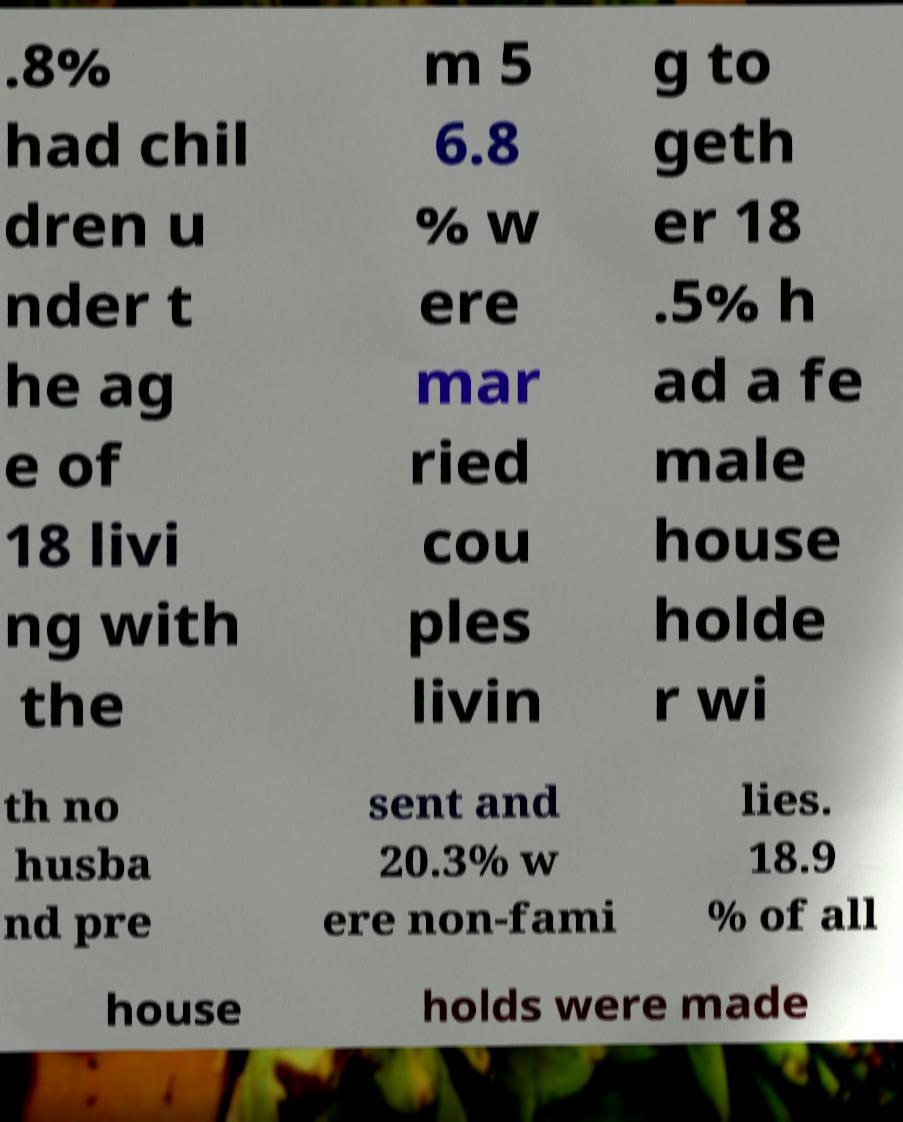Can you accurately transcribe the text from the provided image for me? .8% had chil dren u nder t he ag e of 18 livi ng with the m 5 6.8 % w ere mar ried cou ples livin g to geth er 18 .5% h ad a fe male house holde r wi th no husba nd pre sent and 20.3% w ere non-fami lies. 18.9 % of all house holds were made 